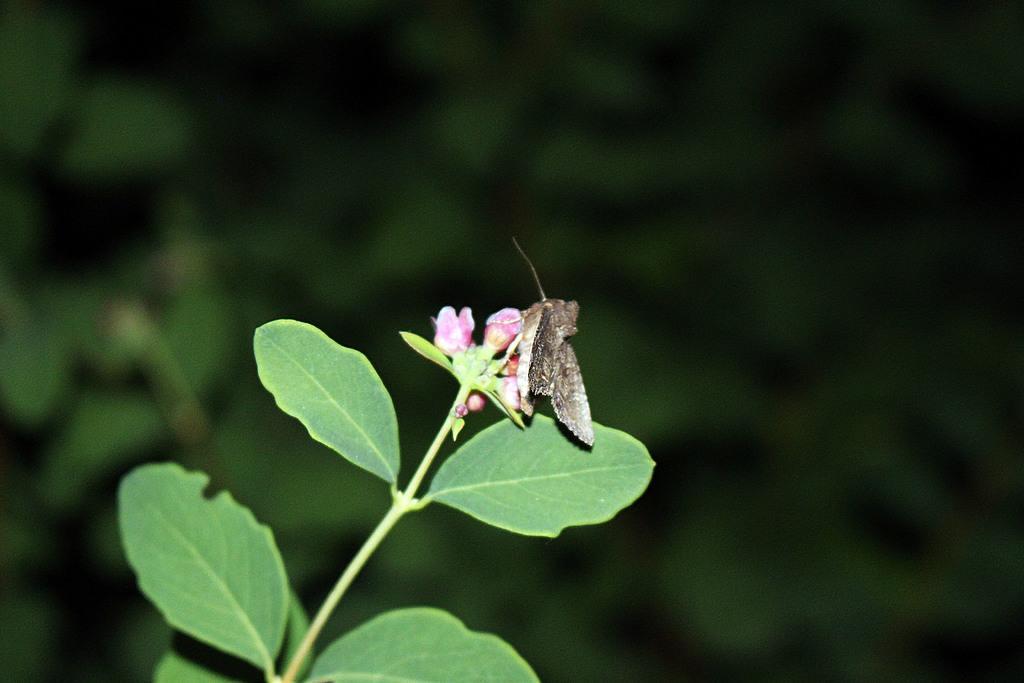How would you summarize this image in a sentence or two? In this picture there is a moth in the center of the image on a bud, there is a plant in the image and the background area of the image is blur. 